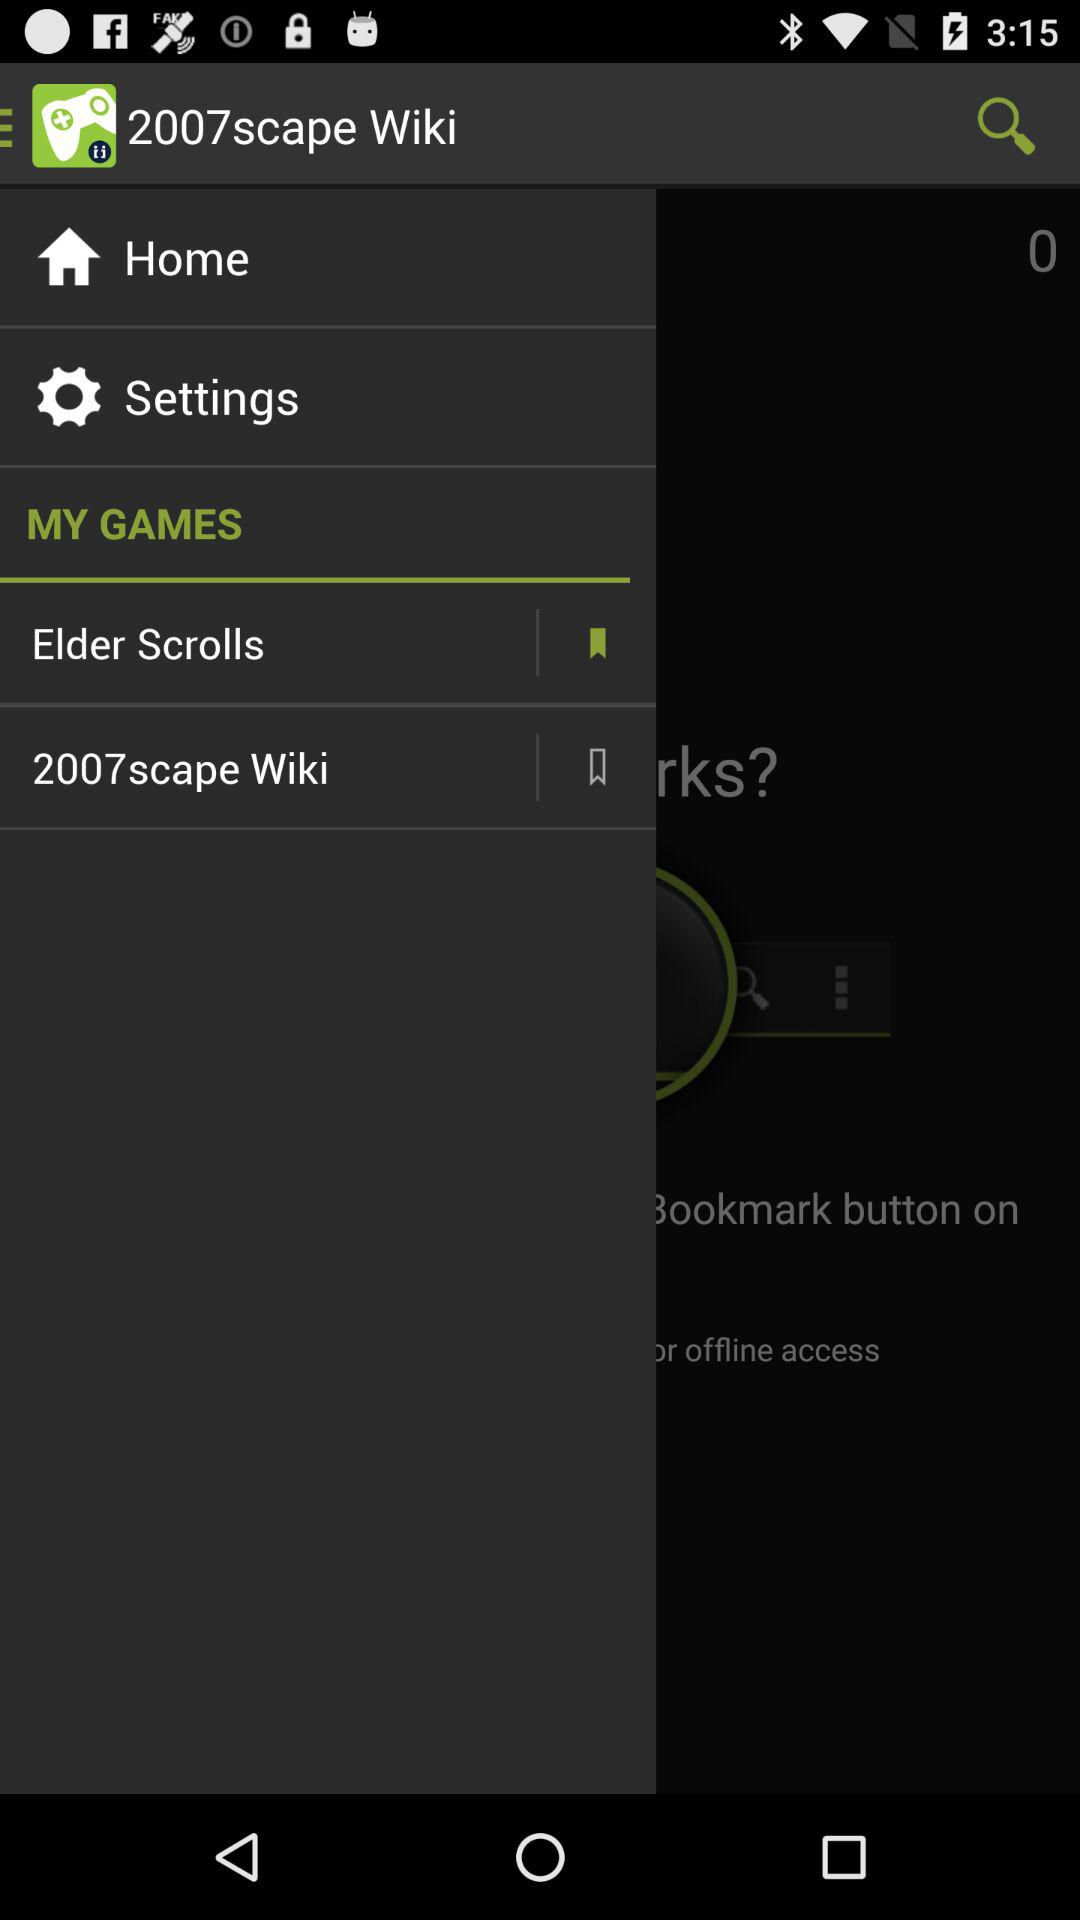How many bookmarks are there?
Answer the question using a single word or phrase. 2 